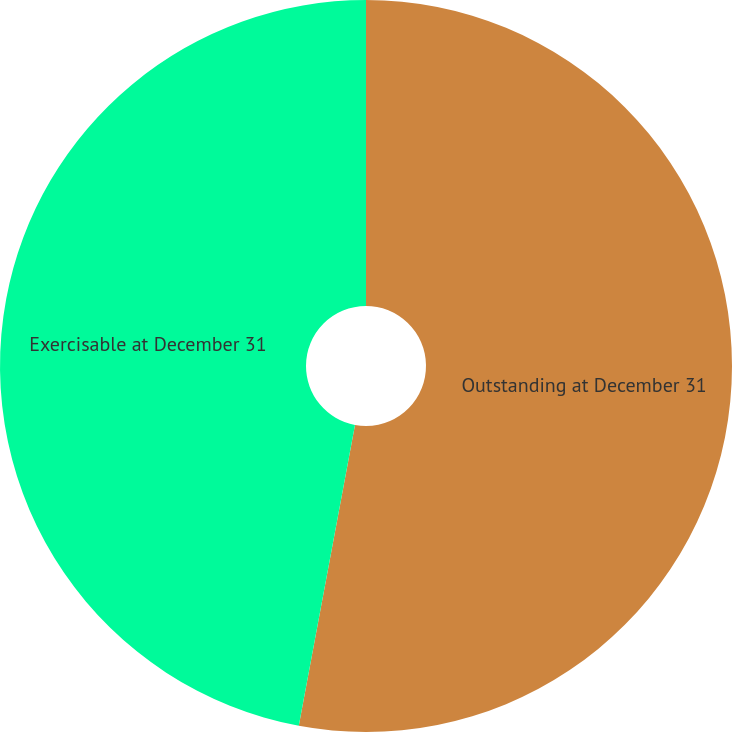<chart> <loc_0><loc_0><loc_500><loc_500><pie_chart><fcel>Outstanding at December 31<fcel>Exercisable at December 31<nl><fcel>52.94%<fcel>47.06%<nl></chart> 